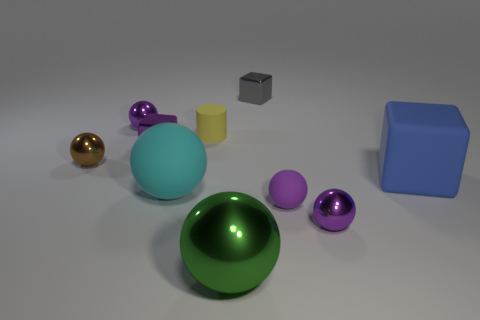How many cubes are metal objects or big green shiny things?
Your response must be concise. 2. How many purple cubes are there?
Make the answer very short. 1. Does the purple matte thing have the same shape as the tiny rubber object that is to the left of the large green thing?
Ensure brevity in your answer.  No. There is a shiny cube that is the same color as the tiny matte sphere; what is its size?
Your answer should be compact. Small. What number of things are brown spheres or cyan objects?
Give a very brief answer. 2. What shape is the metallic thing on the right side of the small shiny block on the right side of the small yellow rubber cylinder?
Keep it short and to the point. Sphere. There is a purple shiny thing that is in front of the purple metallic cube; does it have the same shape as the tiny gray metal object?
Your answer should be compact. No. What is the size of the cyan ball that is made of the same material as the large blue block?
Make the answer very short. Large. How many things are either purple objects that are to the left of the big cyan ball or small purple metal things right of the gray thing?
Make the answer very short. 3. Is the number of big matte balls that are behind the brown metallic thing the same as the number of small brown metallic balls that are left of the cyan matte thing?
Make the answer very short. No. 